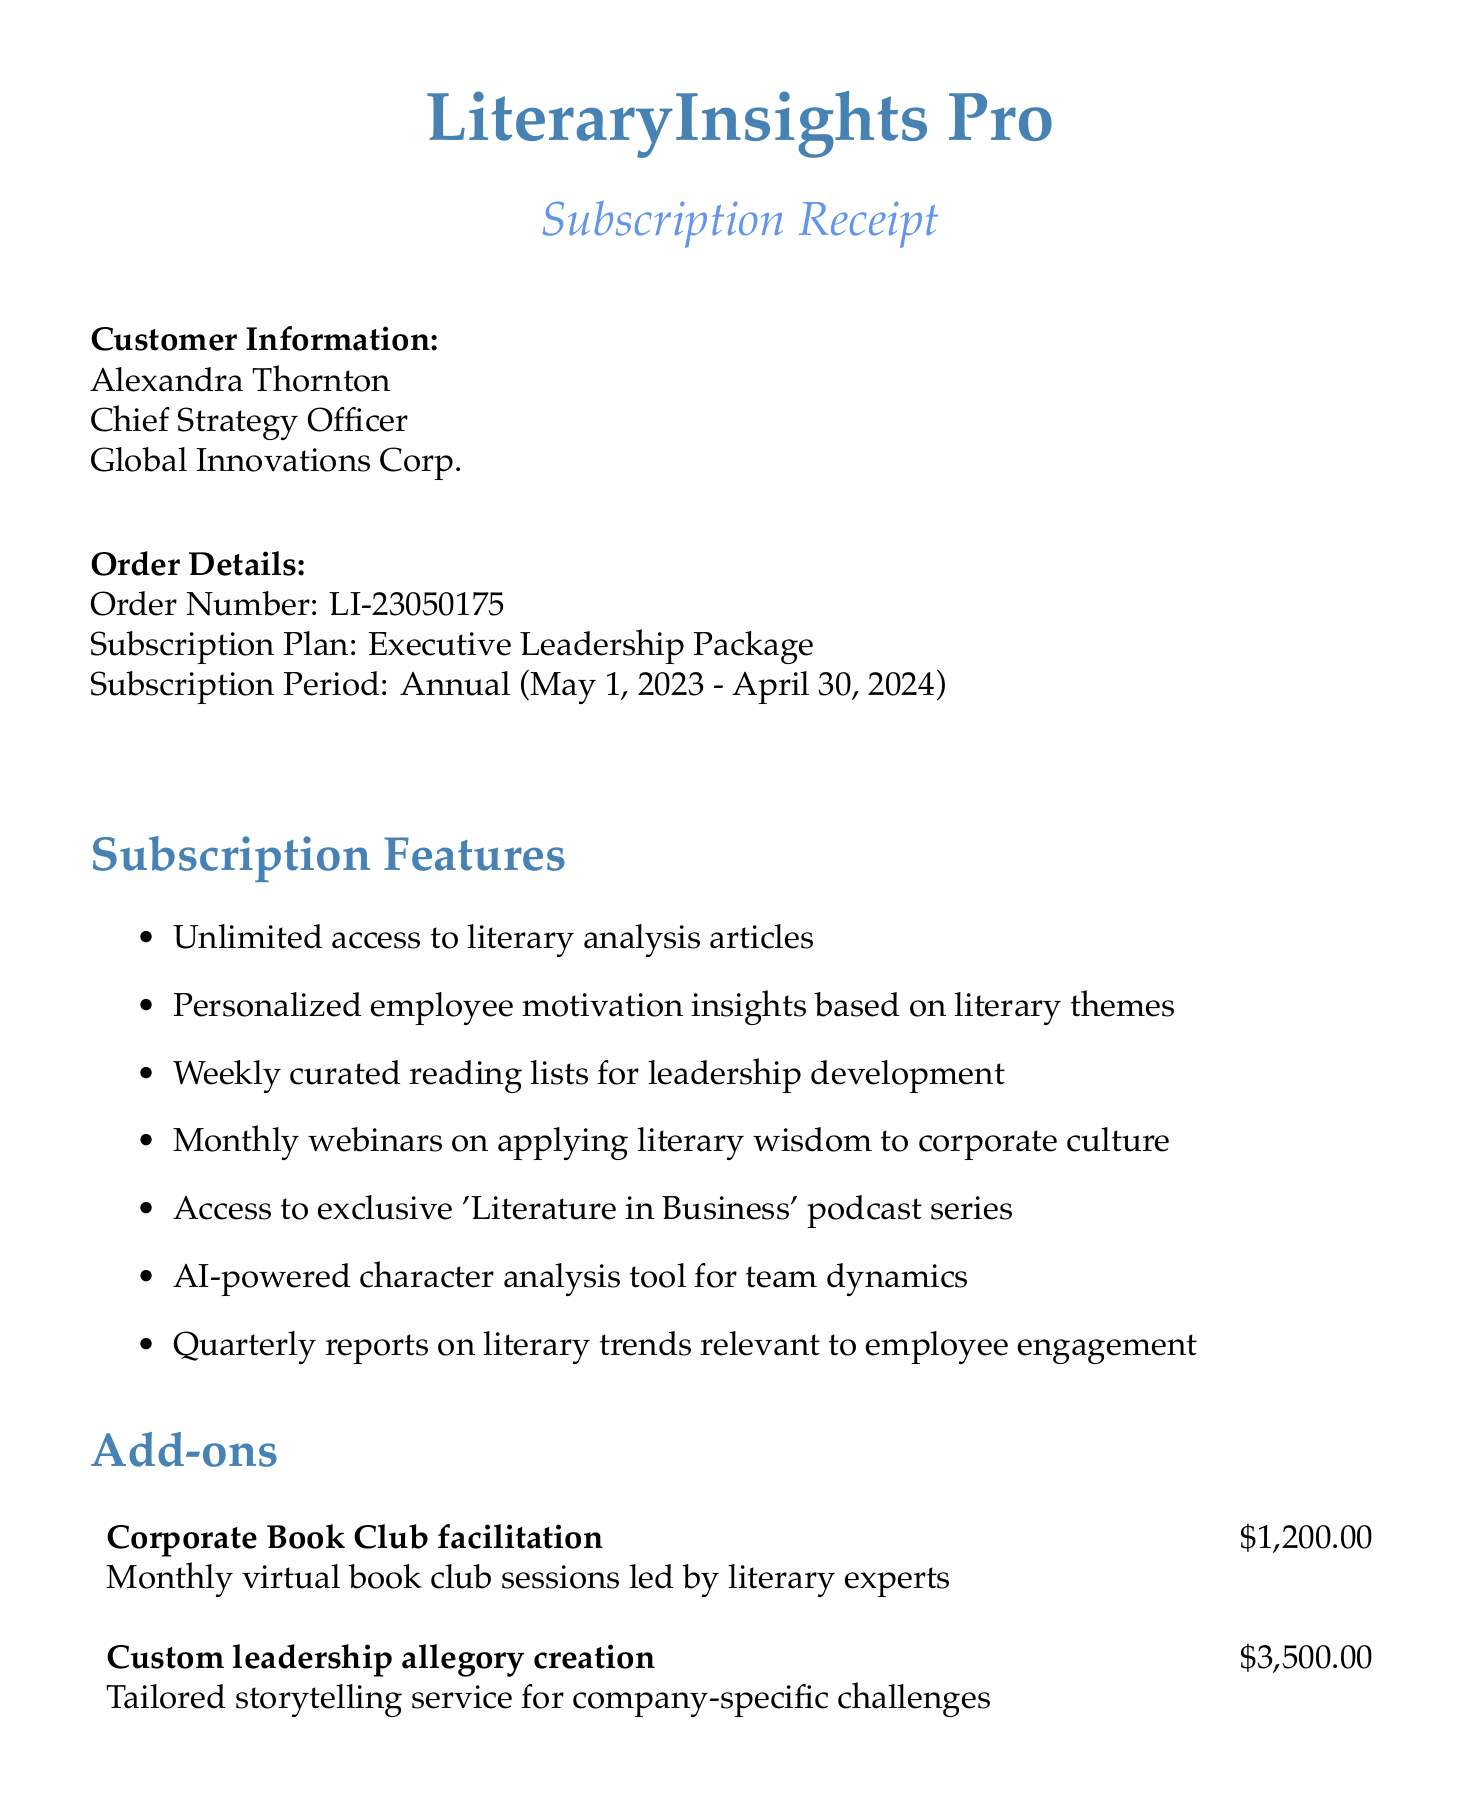What is the customer name? The customer's name is specified in the document under Customer Information.
Answer: Alexandra Thornton What is the subscription plan? The subscription plan is detailed in the Order Details section of the document.
Answer: Executive Leadership Package What is the total amount due? The total amount is provided in the Pricing Summary section, which summarizes the costs.
Answer: $10,378.93 When does the subscription period end? The end date of the subscription period is indicated in the Order Details section.
Answer: April 30, 2024 How many features are included in the subscription? The number of features is given in the Subscription Features section of the document.
Answer: 7 What is the price of the Custom leadership allegory creation add-on? The price of the add-on is mentioned in the Add-ons section.
Answer: $3,500.00 What is the expiration date of the payment method? The expiration date for the corporate credit card is provided in the Payment Information section.
Answer: 09/25 What type of support can the customer contact? The support contact information provides the channels available for reaching support.
Answer: Email and Phone What is the customer’s title? The customer's title is listed under Customer Information.
Answer: Chief Strategy Officer 